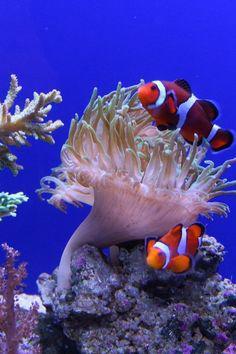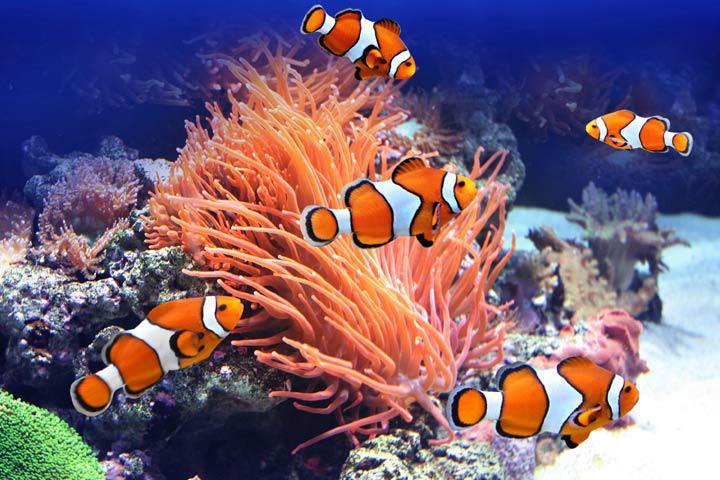The first image is the image on the left, the second image is the image on the right. Given the left and right images, does the statement "An image shows exactly two clown fish swimming by a neutral-colored anemone." hold true? Answer yes or no. Yes. The first image is the image on the left, the second image is the image on the right. Evaluate the accuracy of this statement regarding the images: "There are two clown fish in total.". Is it true? Answer yes or no. No. 